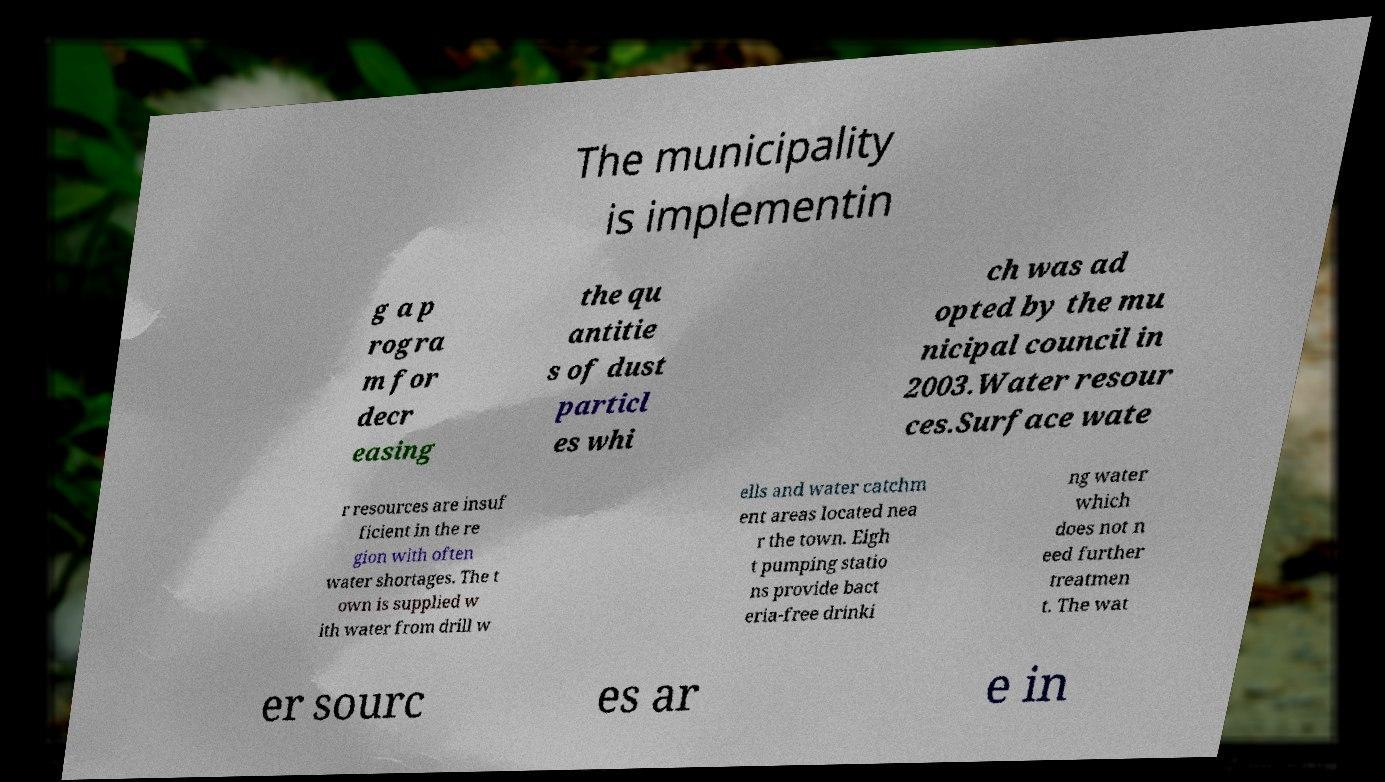There's text embedded in this image that I need extracted. Can you transcribe it verbatim? The municipality is implementin g a p rogra m for decr easing the qu antitie s of dust particl es whi ch was ad opted by the mu nicipal council in 2003.Water resour ces.Surface wate r resources are insuf ficient in the re gion with often water shortages. The t own is supplied w ith water from drill w ells and water catchm ent areas located nea r the town. Eigh t pumping statio ns provide bact eria-free drinki ng water which does not n eed further treatmen t. The wat er sourc es ar e in 